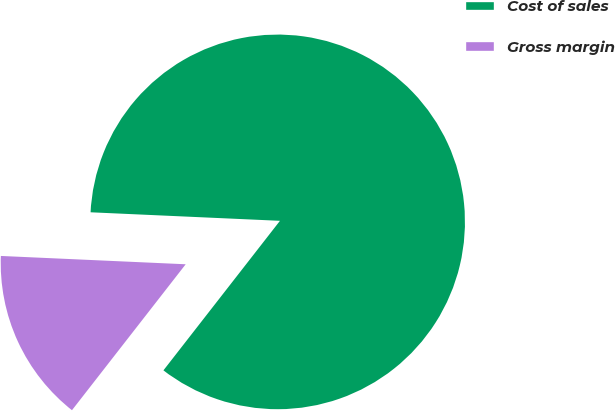Convert chart to OTSL. <chart><loc_0><loc_0><loc_500><loc_500><pie_chart><fcel>Cost of sales<fcel>Gross margin<nl><fcel>84.82%<fcel>15.18%<nl></chart> 